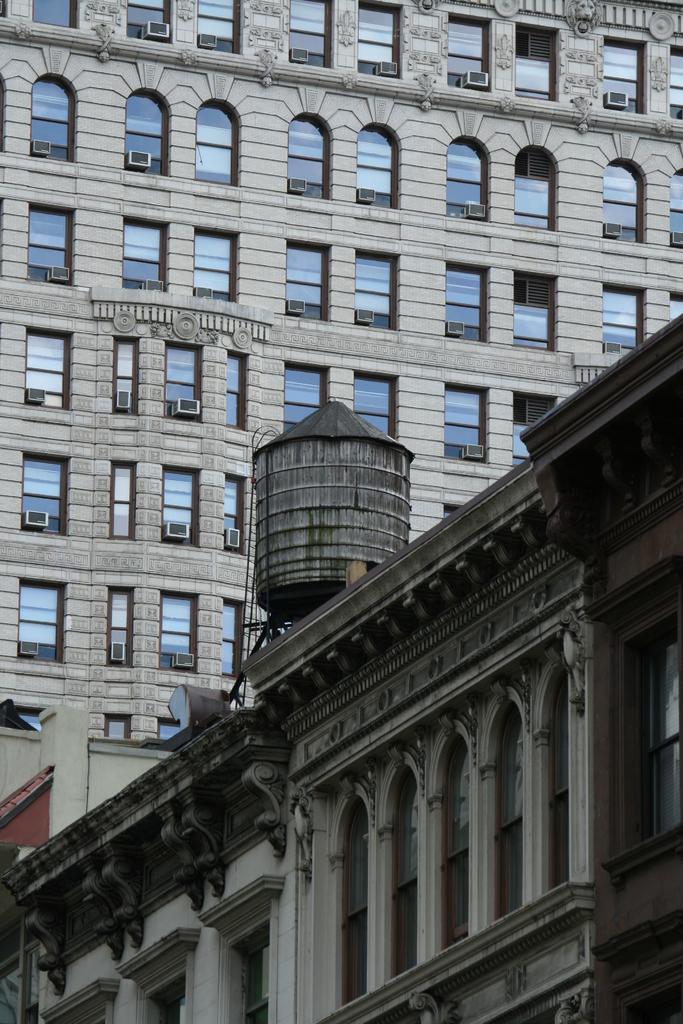Could you give a brief overview of what you see in this image? In this image, we can see buildings. 